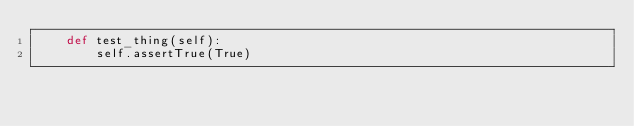<code> <loc_0><loc_0><loc_500><loc_500><_Python_>    def test_thing(self):
        self.assertTrue(True)


</code> 